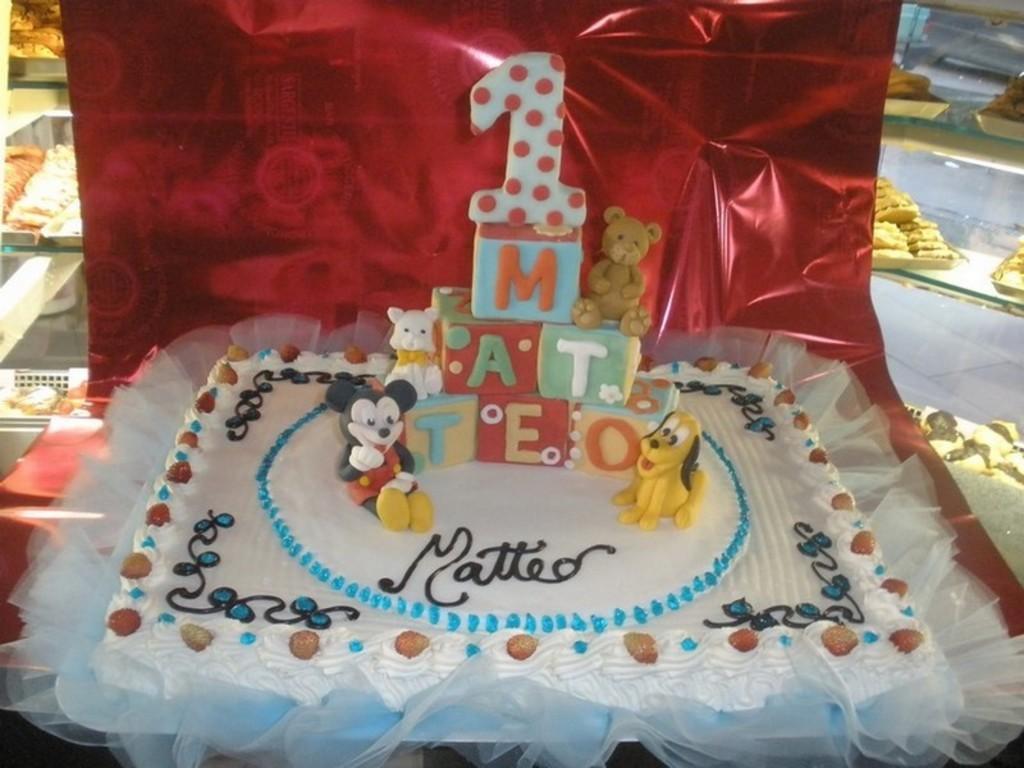Can you describe this image briefly? In the picture there is a birthday cake and behind the cake there are some cookies. 